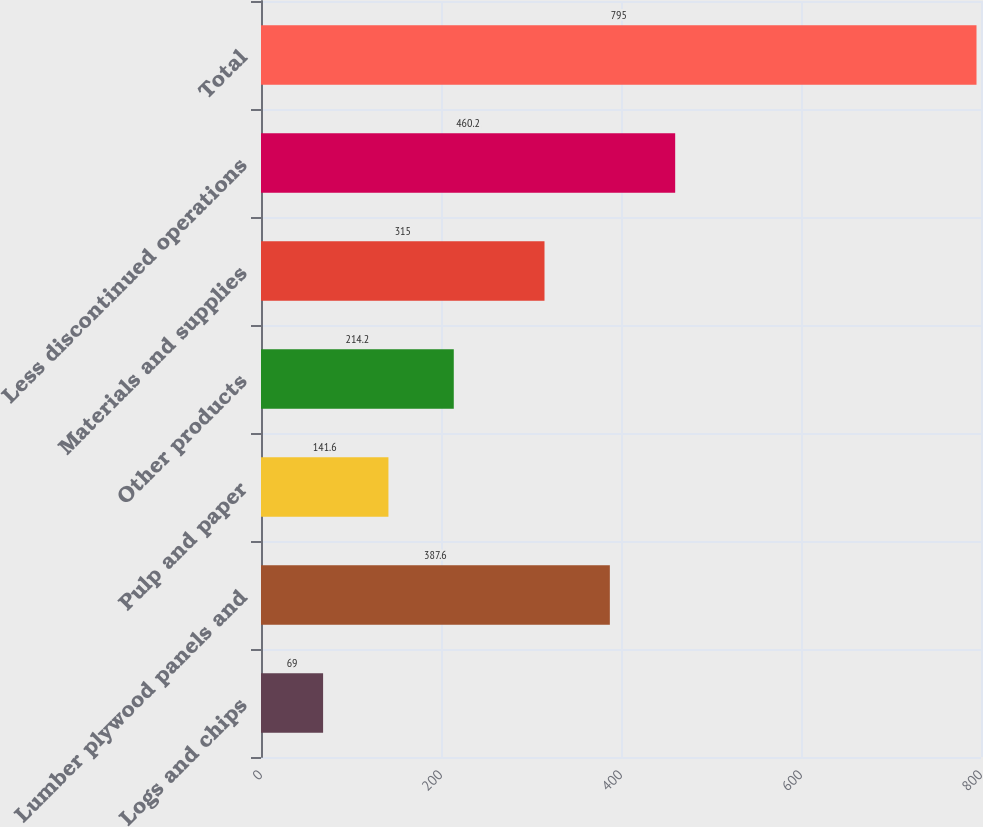Convert chart. <chart><loc_0><loc_0><loc_500><loc_500><bar_chart><fcel>Logs and chips<fcel>Lumber plywood panels and<fcel>Pulp and paper<fcel>Other products<fcel>Materials and supplies<fcel>Less discontinued operations<fcel>Total<nl><fcel>69<fcel>387.6<fcel>141.6<fcel>214.2<fcel>315<fcel>460.2<fcel>795<nl></chart> 